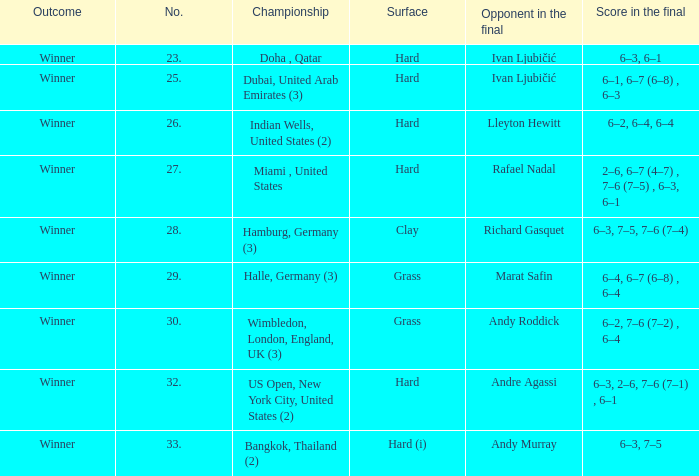On which surface is andy roddick the adversary in the final? Grass. 